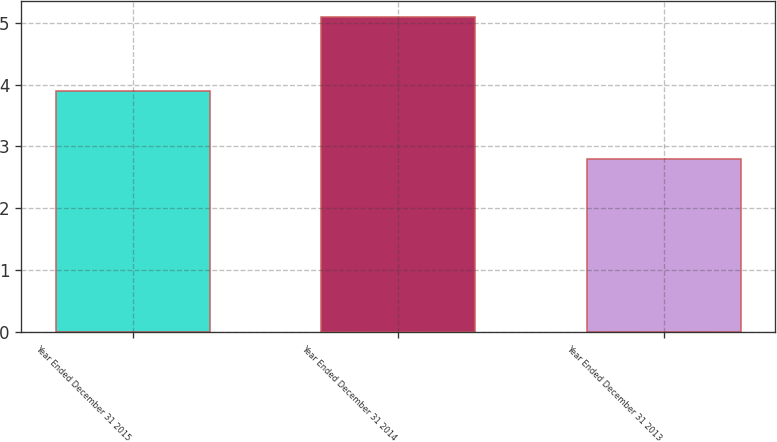<chart> <loc_0><loc_0><loc_500><loc_500><bar_chart><fcel>Year Ended December 31 2015<fcel>Year Ended December 31 2014<fcel>Year Ended December 31 2013<nl><fcel>3.9<fcel>5.1<fcel>2.8<nl></chart> 